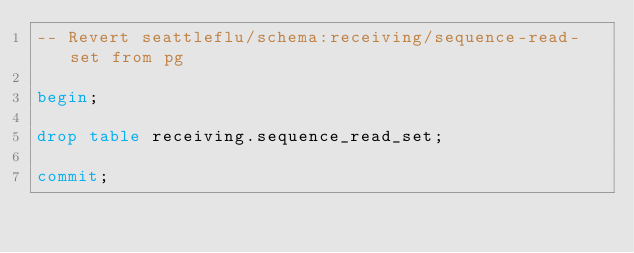Convert code to text. <code><loc_0><loc_0><loc_500><loc_500><_SQL_>-- Revert seattleflu/schema:receiving/sequence-read-set from pg

begin;

drop table receiving.sequence_read_set;

commit;
</code> 